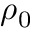Convert formula to latex. <formula><loc_0><loc_0><loc_500><loc_500>\rho _ { 0 }</formula> 